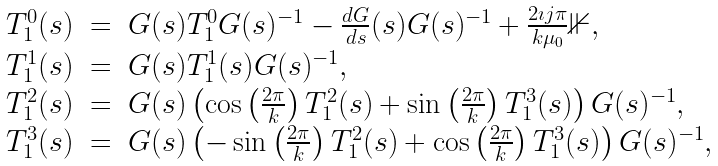<formula> <loc_0><loc_0><loc_500><loc_500>\begin{array} { r c l } T _ { 1 } ^ { 0 } ( s ) & = & G ( s ) T _ { 1 } ^ { 0 } G ( s ) ^ { - 1 } - \frac { d G } { d s } ( s ) G ( s ) ^ { - 1 } + \frac { 2 \imath j \pi } { k \mu _ { 0 } } \mathbb { 1 } , \\ T _ { 1 } ^ { 1 } ( s ) & = & G ( s ) T _ { 1 } ^ { 1 } ( s ) G ( s ) ^ { - 1 } , \\ T _ { 1 } ^ { 2 } ( s ) & = & G ( s ) \left ( \cos \left ( \frac { 2 \pi } { k } \right ) T _ { 1 } ^ { 2 } ( s ) + \sin \left ( \frac { 2 \pi } { k } \right ) T _ { 1 } ^ { 3 } ( s ) \right ) G ( s ) ^ { - 1 } , \\ T _ { 1 } ^ { 3 } ( s ) & = & G ( s ) \left ( - \sin \left ( \frac { 2 \pi } { k } \right ) T _ { 1 } ^ { 2 } ( s ) + \cos \left ( \frac { 2 \pi } { k } \right ) T _ { 1 } ^ { 3 } ( s ) \right ) G ( s ) ^ { - 1 } , \end{array}</formula> 